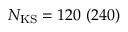<formula> <loc_0><loc_0><loc_500><loc_500>N _ { K S } = 1 2 0 \ ( 2 4 0 )</formula> 